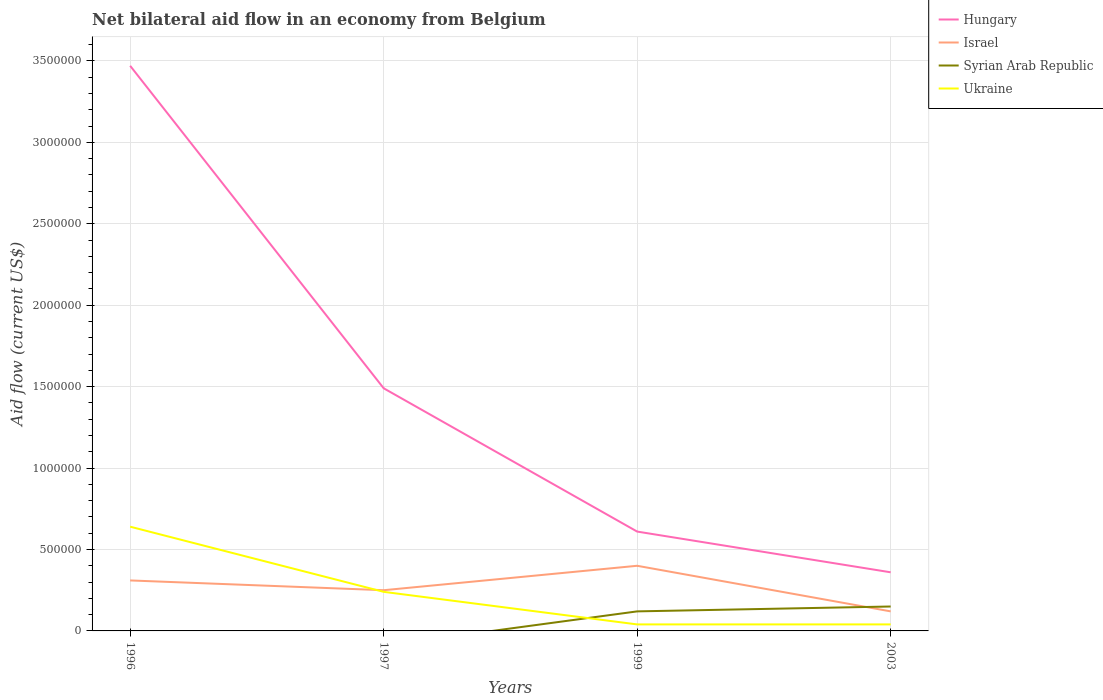Does the line corresponding to Israel intersect with the line corresponding to Ukraine?
Provide a short and direct response. Yes. Is the number of lines equal to the number of legend labels?
Make the answer very short. No. Across all years, what is the maximum net bilateral aid flow in Ukraine?
Offer a terse response. 4.00e+04. What is the total net bilateral aid flow in Hungary in the graph?
Keep it short and to the point. 1.13e+06. How many years are there in the graph?
Your answer should be compact. 4. Are the values on the major ticks of Y-axis written in scientific E-notation?
Your answer should be very brief. No. Does the graph contain grids?
Provide a short and direct response. Yes. What is the title of the graph?
Provide a short and direct response. Net bilateral aid flow in an economy from Belgium. What is the Aid flow (current US$) in Hungary in 1996?
Offer a terse response. 3.47e+06. What is the Aid flow (current US$) of Ukraine in 1996?
Provide a short and direct response. 6.40e+05. What is the Aid flow (current US$) of Hungary in 1997?
Your answer should be compact. 1.49e+06. What is the Aid flow (current US$) in Israel in 1997?
Offer a very short reply. 2.50e+05. What is the Aid flow (current US$) in Syrian Arab Republic in 1997?
Your answer should be compact. 0. What is the Aid flow (current US$) of Ukraine in 1997?
Provide a short and direct response. 2.40e+05. What is the Aid flow (current US$) of Syrian Arab Republic in 2003?
Your response must be concise. 1.50e+05. What is the Aid flow (current US$) of Ukraine in 2003?
Your answer should be compact. 4.00e+04. Across all years, what is the maximum Aid flow (current US$) of Hungary?
Keep it short and to the point. 3.47e+06. Across all years, what is the maximum Aid flow (current US$) of Syrian Arab Republic?
Provide a succinct answer. 1.50e+05. Across all years, what is the maximum Aid flow (current US$) in Ukraine?
Offer a terse response. 6.40e+05. Across all years, what is the minimum Aid flow (current US$) of Israel?
Provide a succinct answer. 1.20e+05. Across all years, what is the minimum Aid flow (current US$) of Syrian Arab Republic?
Keep it short and to the point. 0. Across all years, what is the minimum Aid flow (current US$) of Ukraine?
Keep it short and to the point. 4.00e+04. What is the total Aid flow (current US$) of Hungary in the graph?
Give a very brief answer. 5.93e+06. What is the total Aid flow (current US$) in Israel in the graph?
Give a very brief answer. 1.08e+06. What is the total Aid flow (current US$) in Syrian Arab Republic in the graph?
Provide a short and direct response. 2.70e+05. What is the total Aid flow (current US$) of Ukraine in the graph?
Keep it short and to the point. 9.60e+05. What is the difference between the Aid flow (current US$) of Hungary in 1996 and that in 1997?
Provide a succinct answer. 1.98e+06. What is the difference between the Aid flow (current US$) in Israel in 1996 and that in 1997?
Give a very brief answer. 6.00e+04. What is the difference between the Aid flow (current US$) of Ukraine in 1996 and that in 1997?
Your response must be concise. 4.00e+05. What is the difference between the Aid flow (current US$) of Hungary in 1996 and that in 1999?
Give a very brief answer. 2.86e+06. What is the difference between the Aid flow (current US$) of Hungary in 1996 and that in 2003?
Ensure brevity in your answer.  3.11e+06. What is the difference between the Aid flow (current US$) in Israel in 1996 and that in 2003?
Ensure brevity in your answer.  1.90e+05. What is the difference between the Aid flow (current US$) in Ukraine in 1996 and that in 2003?
Your answer should be compact. 6.00e+05. What is the difference between the Aid flow (current US$) of Hungary in 1997 and that in 1999?
Provide a short and direct response. 8.80e+05. What is the difference between the Aid flow (current US$) in Hungary in 1997 and that in 2003?
Your answer should be very brief. 1.13e+06. What is the difference between the Aid flow (current US$) in Hungary in 1999 and that in 2003?
Your answer should be compact. 2.50e+05. What is the difference between the Aid flow (current US$) of Syrian Arab Republic in 1999 and that in 2003?
Provide a succinct answer. -3.00e+04. What is the difference between the Aid flow (current US$) in Hungary in 1996 and the Aid flow (current US$) in Israel in 1997?
Give a very brief answer. 3.22e+06. What is the difference between the Aid flow (current US$) in Hungary in 1996 and the Aid flow (current US$) in Ukraine in 1997?
Make the answer very short. 3.23e+06. What is the difference between the Aid flow (current US$) of Israel in 1996 and the Aid flow (current US$) of Ukraine in 1997?
Give a very brief answer. 7.00e+04. What is the difference between the Aid flow (current US$) of Hungary in 1996 and the Aid flow (current US$) of Israel in 1999?
Provide a short and direct response. 3.07e+06. What is the difference between the Aid flow (current US$) of Hungary in 1996 and the Aid flow (current US$) of Syrian Arab Republic in 1999?
Your answer should be compact. 3.35e+06. What is the difference between the Aid flow (current US$) of Hungary in 1996 and the Aid flow (current US$) of Ukraine in 1999?
Your response must be concise. 3.43e+06. What is the difference between the Aid flow (current US$) in Hungary in 1996 and the Aid flow (current US$) in Israel in 2003?
Your response must be concise. 3.35e+06. What is the difference between the Aid flow (current US$) of Hungary in 1996 and the Aid flow (current US$) of Syrian Arab Republic in 2003?
Your response must be concise. 3.32e+06. What is the difference between the Aid flow (current US$) in Hungary in 1996 and the Aid flow (current US$) in Ukraine in 2003?
Offer a very short reply. 3.43e+06. What is the difference between the Aid flow (current US$) in Hungary in 1997 and the Aid flow (current US$) in Israel in 1999?
Ensure brevity in your answer.  1.09e+06. What is the difference between the Aid flow (current US$) of Hungary in 1997 and the Aid flow (current US$) of Syrian Arab Republic in 1999?
Give a very brief answer. 1.37e+06. What is the difference between the Aid flow (current US$) of Hungary in 1997 and the Aid flow (current US$) of Ukraine in 1999?
Offer a terse response. 1.45e+06. What is the difference between the Aid flow (current US$) in Israel in 1997 and the Aid flow (current US$) in Ukraine in 1999?
Offer a terse response. 2.10e+05. What is the difference between the Aid flow (current US$) in Hungary in 1997 and the Aid flow (current US$) in Israel in 2003?
Offer a terse response. 1.37e+06. What is the difference between the Aid flow (current US$) of Hungary in 1997 and the Aid flow (current US$) of Syrian Arab Republic in 2003?
Your response must be concise. 1.34e+06. What is the difference between the Aid flow (current US$) in Hungary in 1997 and the Aid flow (current US$) in Ukraine in 2003?
Make the answer very short. 1.45e+06. What is the difference between the Aid flow (current US$) in Hungary in 1999 and the Aid flow (current US$) in Syrian Arab Republic in 2003?
Give a very brief answer. 4.60e+05. What is the difference between the Aid flow (current US$) in Hungary in 1999 and the Aid flow (current US$) in Ukraine in 2003?
Your answer should be compact. 5.70e+05. What is the difference between the Aid flow (current US$) in Israel in 1999 and the Aid flow (current US$) in Syrian Arab Republic in 2003?
Your answer should be compact. 2.50e+05. What is the difference between the Aid flow (current US$) in Syrian Arab Republic in 1999 and the Aid flow (current US$) in Ukraine in 2003?
Provide a succinct answer. 8.00e+04. What is the average Aid flow (current US$) of Hungary per year?
Offer a terse response. 1.48e+06. What is the average Aid flow (current US$) of Israel per year?
Your response must be concise. 2.70e+05. What is the average Aid flow (current US$) in Syrian Arab Republic per year?
Keep it short and to the point. 6.75e+04. What is the average Aid flow (current US$) of Ukraine per year?
Your answer should be very brief. 2.40e+05. In the year 1996, what is the difference between the Aid flow (current US$) in Hungary and Aid flow (current US$) in Israel?
Your answer should be compact. 3.16e+06. In the year 1996, what is the difference between the Aid flow (current US$) in Hungary and Aid flow (current US$) in Ukraine?
Keep it short and to the point. 2.83e+06. In the year 1996, what is the difference between the Aid flow (current US$) of Israel and Aid flow (current US$) of Ukraine?
Your response must be concise. -3.30e+05. In the year 1997, what is the difference between the Aid flow (current US$) of Hungary and Aid flow (current US$) of Israel?
Offer a terse response. 1.24e+06. In the year 1997, what is the difference between the Aid flow (current US$) of Hungary and Aid flow (current US$) of Ukraine?
Provide a succinct answer. 1.25e+06. In the year 1997, what is the difference between the Aid flow (current US$) of Israel and Aid flow (current US$) of Ukraine?
Offer a terse response. 10000. In the year 1999, what is the difference between the Aid flow (current US$) in Hungary and Aid flow (current US$) in Israel?
Keep it short and to the point. 2.10e+05. In the year 1999, what is the difference between the Aid flow (current US$) in Hungary and Aid flow (current US$) in Syrian Arab Republic?
Ensure brevity in your answer.  4.90e+05. In the year 1999, what is the difference between the Aid flow (current US$) of Hungary and Aid flow (current US$) of Ukraine?
Give a very brief answer. 5.70e+05. In the year 1999, what is the difference between the Aid flow (current US$) of Israel and Aid flow (current US$) of Syrian Arab Republic?
Provide a succinct answer. 2.80e+05. In the year 2003, what is the difference between the Aid flow (current US$) of Hungary and Aid flow (current US$) of Israel?
Your answer should be compact. 2.40e+05. In the year 2003, what is the difference between the Aid flow (current US$) of Hungary and Aid flow (current US$) of Syrian Arab Republic?
Offer a very short reply. 2.10e+05. In the year 2003, what is the difference between the Aid flow (current US$) of Syrian Arab Republic and Aid flow (current US$) of Ukraine?
Your answer should be compact. 1.10e+05. What is the ratio of the Aid flow (current US$) in Hungary in 1996 to that in 1997?
Keep it short and to the point. 2.33. What is the ratio of the Aid flow (current US$) of Israel in 1996 to that in 1997?
Offer a terse response. 1.24. What is the ratio of the Aid flow (current US$) in Ukraine in 1996 to that in 1997?
Your answer should be very brief. 2.67. What is the ratio of the Aid flow (current US$) in Hungary in 1996 to that in 1999?
Keep it short and to the point. 5.69. What is the ratio of the Aid flow (current US$) of Israel in 1996 to that in 1999?
Keep it short and to the point. 0.78. What is the ratio of the Aid flow (current US$) of Hungary in 1996 to that in 2003?
Your answer should be compact. 9.64. What is the ratio of the Aid flow (current US$) in Israel in 1996 to that in 2003?
Offer a terse response. 2.58. What is the ratio of the Aid flow (current US$) of Ukraine in 1996 to that in 2003?
Provide a short and direct response. 16. What is the ratio of the Aid flow (current US$) of Hungary in 1997 to that in 1999?
Keep it short and to the point. 2.44. What is the ratio of the Aid flow (current US$) of Israel in 1997 to that in 1999?
Make the answer very short. 0.62. What is the ratio of the Aid flow (current US$) in Ukraine in 1997 to that in 1999?
Keep it short and to the point. 6. What is the ratio of the Aid flow (current US$) of Hungary in 1997 to that in 2003?
Give a very brief answer. 4.14. What is the ratio of the Aid flow (current US$) of Israel in 1997 to that in 2003?
Offer a very short reply. 2.08. What is the ratio of the Aid flow (current US$) in Ukraine in 1997 to that in 2003?
Your response must be concise. 6. What is the ratio of the Aid flow (current US$) of Hungary in 1999 to that in 2003?
Your response must be concise. 1.69. What is the ratio of the Aid flow (current US$) of Syrian Arab Republic in 1999 to that in 2003?
Provide a short and direct response. 0.8. What is the ratio of the Aid flow (current US$) in Ukraine in 1999 to that in 2003?
Ensure brevity in your answer.  1. What is the difference between the highest and the second highest Aid flow (current US$) of Hungary?
Ensure brevity in your answer.  1.98e+06. What is the difference between the highest and the second highest Aid flow (current US$) in Israel?
Provide a short and direct response. 9.00e+04. What is the difference between the highest and the second highest Aid flow (current US$) in Ukraine?
Your response must be concise. 4.00e+05. What is the difference between the highest and the lowest Aid flow (current US$) of Hungary?
Provide a succinct answer. 3.11e+06. What is the difference between the highest and the lowest Aid flow (current US$) of Syrian Arab Republic?
Make the answer very short. 1.50e+05. What is the difference between the highest and the lowest Aid flow (current US$) of Ukraine?
Your response must be concise. 6.00e+05. 